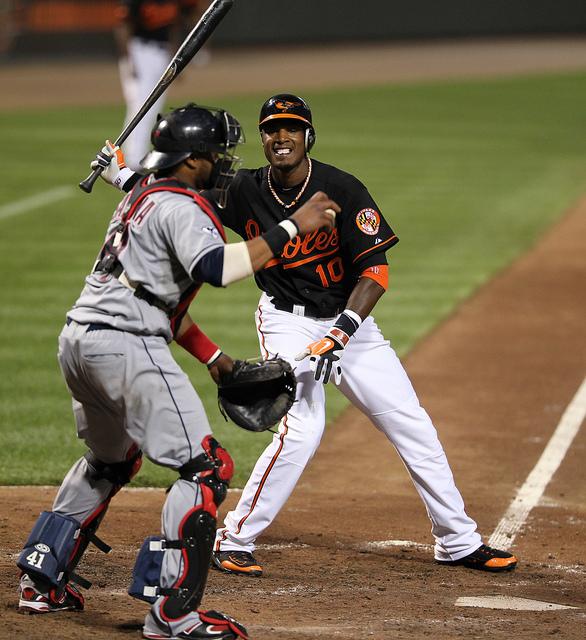What is in the catcher's right hand?
Keep it brief. Ball. Is the man left handed?
Write a very short answer. No. What is the catcher about to do?
Keep it brief. Throw ball. What game is this?
Keep it brief. Baseball. What color is the uniform?
Write a very short answer. Black. 